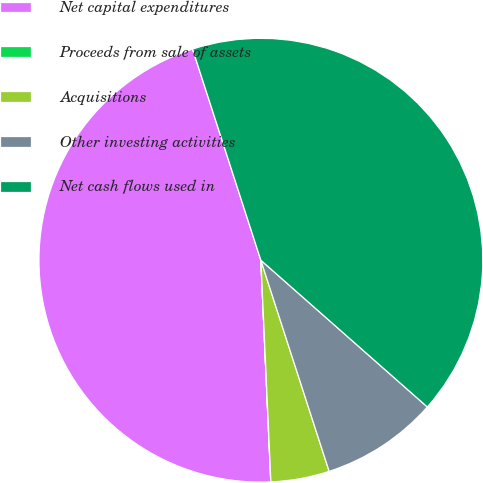Convert chart to OTSL. <chart><loc_0><loc_0><loc_500><loc_500><pie_chart><fcel>Net capital expenditures<fcel>Proceeds from sale of assets<fcel>Acquisitions<fcel>Other investing activities<fcel>Net cash flows used in<nl><fcel>45.73%<fcel>0.01%<fcel>4.26%<fcel>8.52%<fcel>41.48%<nl></chart> 